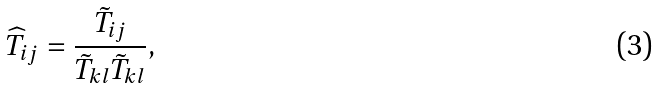<formula> <loc_0><loc_0><loc_500><loc_500>\widehat { T } _ { i j } = \frac { \tilde { T } _ { i j } } { \tilde { T } _ { k l } \tilde { T } _ { k l } } ,</formula> 